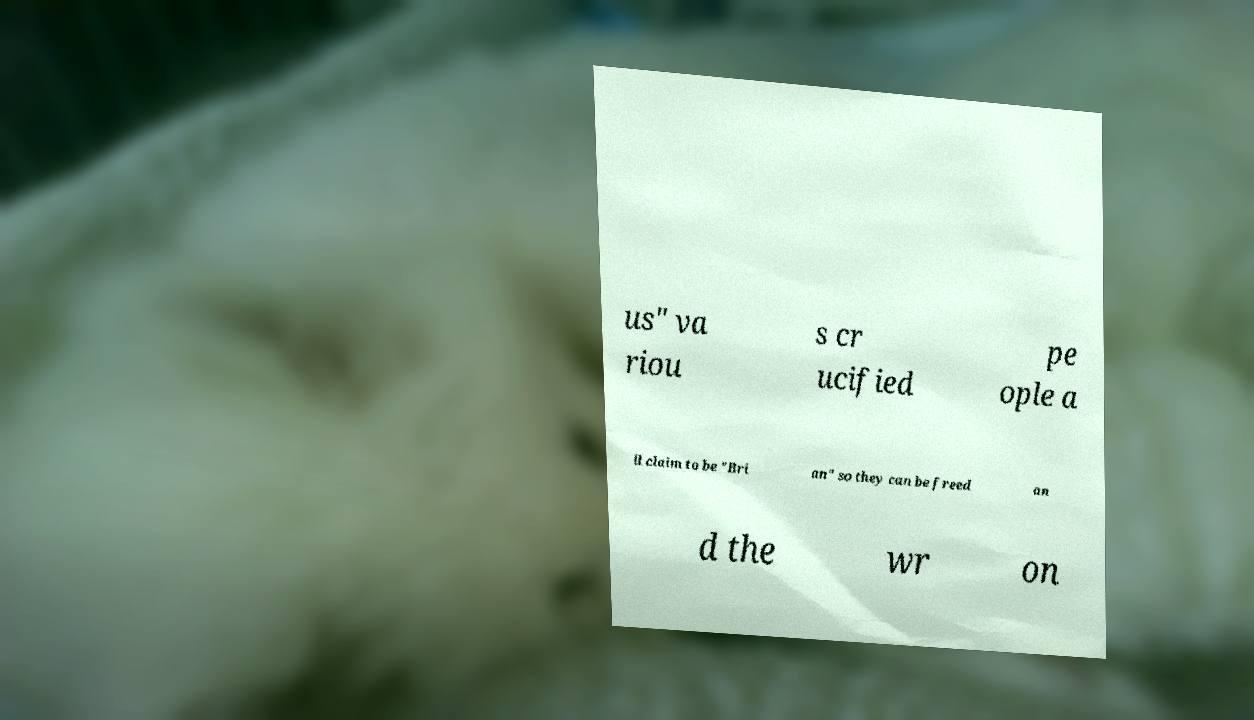Please read and relay the text visible in this image. What does it say? us" va riou s cr ucified pe ople a ll claim to be "Bri an" so they can be freed an d the wr on 